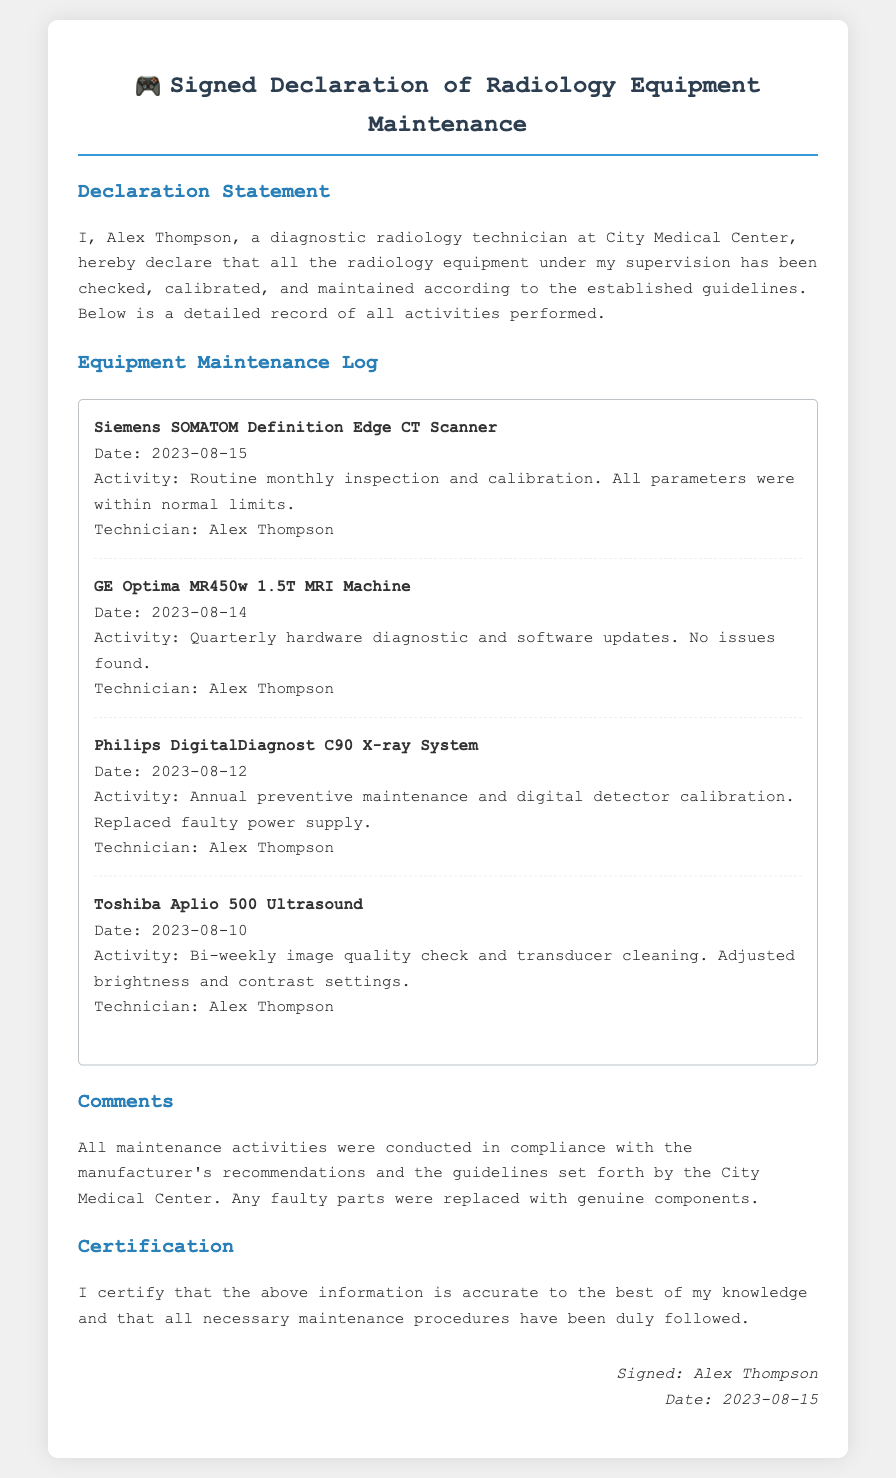what is the technician's name? The technician's name is mentioned in the declaration statement and appears multiple times in the log entries.
Answer: Alex Thompson what is the date of the maintenance log? The date is provided in the signature section of the document where the technician certifies the information.
Answer: 2023-08-15 how many equipment items are listed in the maintenance log? The number of equipment items can be counted directly from the maintenance log section, there are four individual entries.
Answer: 4 what activity was performed on the Philips DigitalDiagnost C90 X-ray System? The activity performed is detailed within the log entry corresponding to this equipment, noting all specific actions taken.
Answer: Annual preventive maintenance and digital detector calibration which equipment had a faulty power supply replaced? The log provides a direct mention of which equipment required a part replacement through its recorded activity.
Answer: Philips DigitalDiagnost C90 X-ray System what was adjusted during the Toshiba Aplio 500 Ultrasound maintenance? The specific adjustments made are noted in the activity description for this equipment in the maintenance log.
Answer: brightness and contrast settings when was the routine monthly inspection conducted? This date is stated alongside the specific equipment and activity performed in the maintenance log.
Answer: 2023-08-15 what is stated in the comments regarding parts? The comments reflect on compliance and replacements of parts, highlighting quality assurance in maintenance practices.
Answer: genuine components 